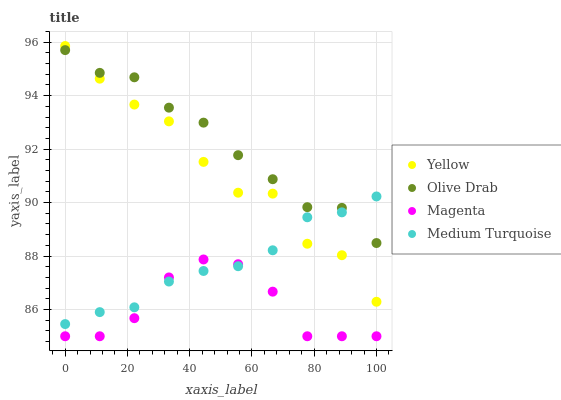Does Magenta have the minimum area under the curve?
Answer yes or no. Yes. Does Olive Drab have the maximum area under the curve?
Answer yes or no. Yes. Does Yellow have the minimum area under the curve?
Answer yes or no. No. Does Yellow have the maximum area under the curve?
Answer yes or no. No. Is Medium Turquoise the smoothest?
Answer yes or no. Yes. Is Yellow the roughest?
Answer yes or no. Yes. Is Olive Drab the smoothest?
Answer yes or no. No. Is Olive Drab the roughest?
Answer yes or no. No. Does Magenta have the lowest value?
Answer yes or no. Yes. Does Yellow have the lowest value?
Answer yes or no. No. Does Yellow have the highest value?
Answer yes or no. Yes. Does Olive Drab have the highest value?
Answer yes or no. No. Is Magenta less than Olive Drab?
Answer yes or no. Yes. Is Yellow greater than Magenta?
Answer yes or no. Yes. Does Medium Turquoise intersect Olive Drab?
Answer yes or no. Yes. Is Medium Turquoise less than Olive Drab?
Answer yes or no. No. Is Medium Turquoise greater than Olive Drab?
Answer yes or no. No. Does Magenta intersect Olive Drab?
Answer yes or no. No. 